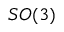<formula> <loc_0><loc_0><loc_500><loc_500>S O ( 3 )</formula> 